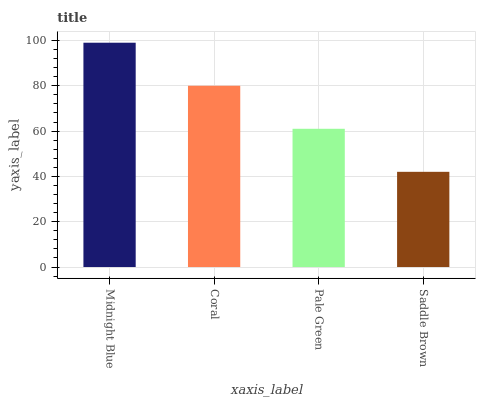Is Saddle Brown the minimum?
Answer yes or no. Yes. Is Midnight Blue the maximum?
Answer yes or no. Yes. Is Coral the minimum?
Answer yes or no. No. Is Coral the maximum?
Answer yes or no. No. Is Midnight Blue greater than Coral?
Answer yes or no. Yes. Is Coral less than Midnight Blue?
Answer yes or no. Yes. Is Coral greater than Midnight Blue?
Answer yes or no. No. Is Midnight Blue less than Coral?
Answer yes or no. No. Is Coral the high median?
Answer yes or no. Yes. Is Pale Green the low median?
Answer yes or no. Yes. Is Midnight Blue the high median?
Answer yes or no. No. Is Coral the low median?
Answer yes or no. No. 